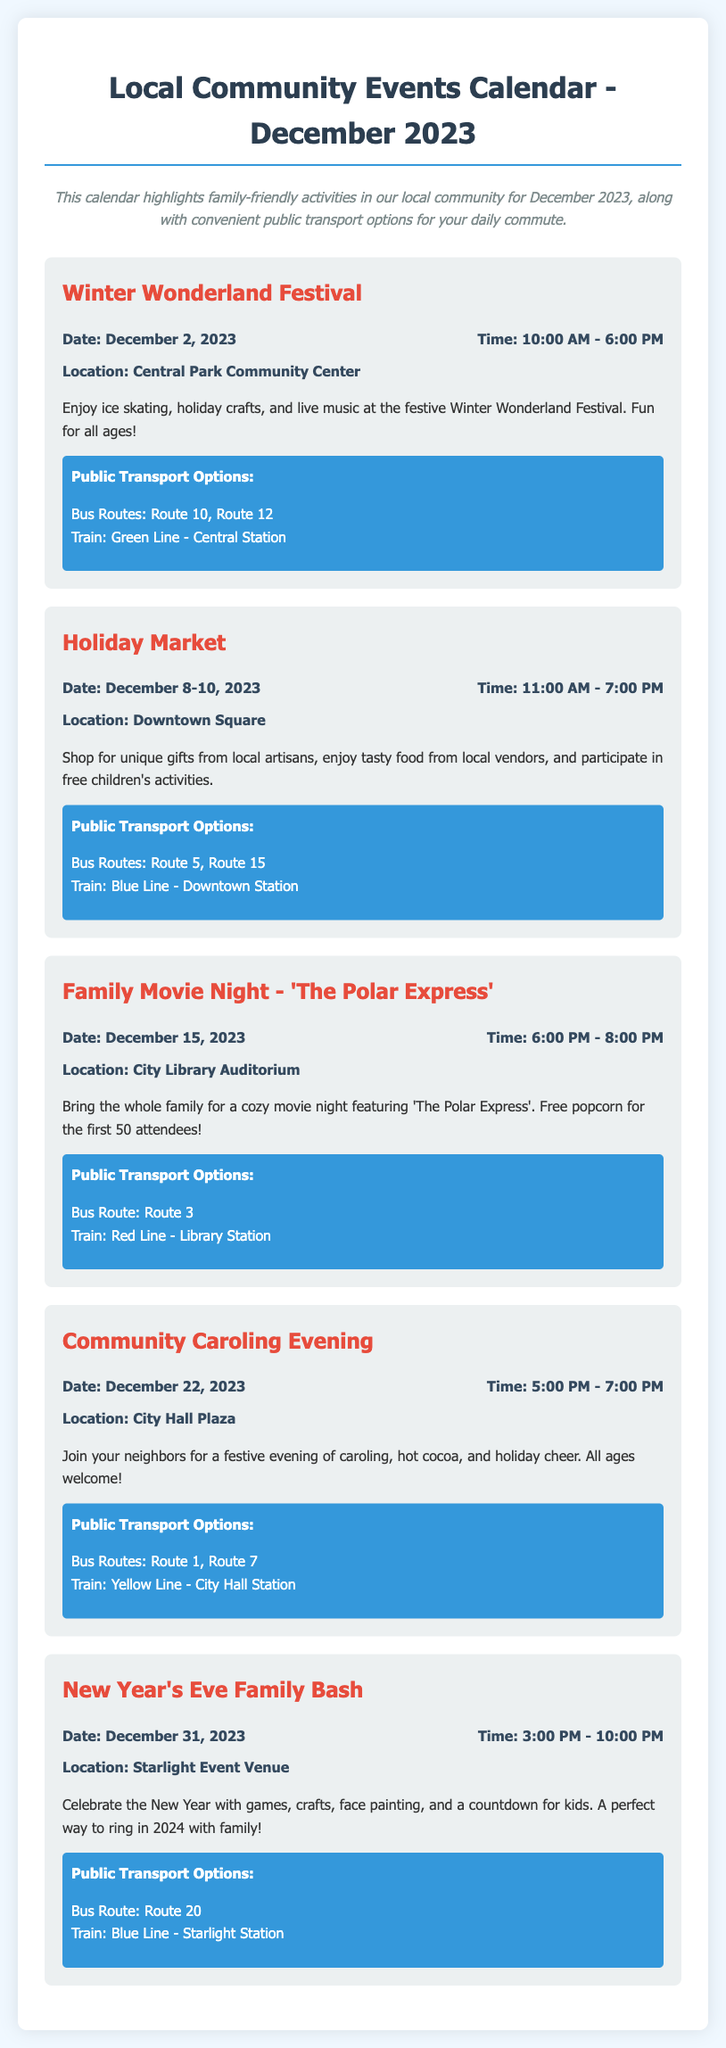What is the date of the Winter Wonderland Festival? The Winter Wonderland Festival is scheduled for December 2, 2023, as stated in the event details.
Answer: December 2, 2023 What time does the Holiday Market start? The Holiday Market opens at 11:00 AM, according to the event time listed.
Answer: 11:00 AM Where is the Family Movie Night taking place? The Family Movie Night will be held at the City Library Auditorium, as mentioned in the location details.
Answer: City Library Auditorium Which bus route is available for the Community Caroling Evening? The Community Caroling Evening is accessible via Bus Routes 1 and 7, provided in the transport options.
Answer: Route 1, Route 7 How long is the New Year's Eve Family Bash? The New Year's Eve Family Bash lasts from 3:00 PM to 10:00 PM, therefore it is 7 hours long.
Answer: 7 hours What special feature is available for attendees of the Family Movie Night? The event offers free popcorn for the first 50 attendees, highlighting a special feature.
Answer: Free popcorn What type of activities can families enjoy at the Winter Wonderland Festival? The festival includes ice skating, holiday crafts, and live music, making it family-friendly.
Answer: Ice skating, holiday crafts, live music What is the location of the Holiday Market? The Holiday Market will be located at Downtown Square, as indicated in the location details.
Answer: Downtown Square Which train line can be taken to reach the Winter Wonderland Festival? Attendees can use the Green Line to Central Station to reach the festival, noted in the transport section.
Answer: Green Line - Central Station 